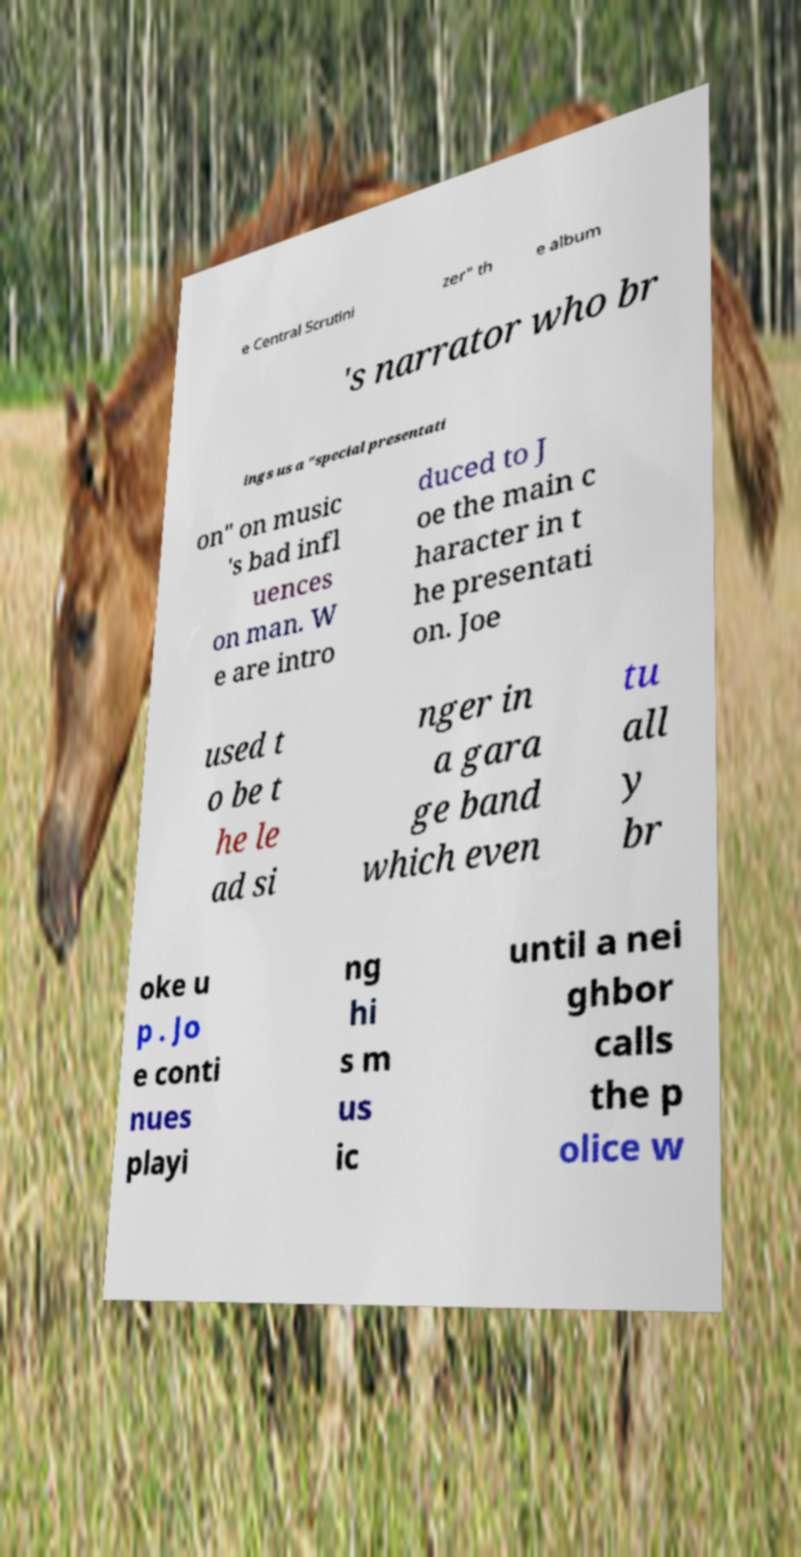Can you read and provide the text displayed in the image?This photo seems to have some interesting text. Can you extract and type it out for me? e Central Scrutini zer" th e album 's narrator who br ings us a "special presentati on" on music 's bad infl uences on man. W e are intro duced to J oe the main c haracter in t he presentati on. Joe used t o be t he le ad si nger in a gara ge band which even tu all y br oke u p . Jo e conti nues playi ng hi s m us ic until a nei ghbor calls the p olice w 